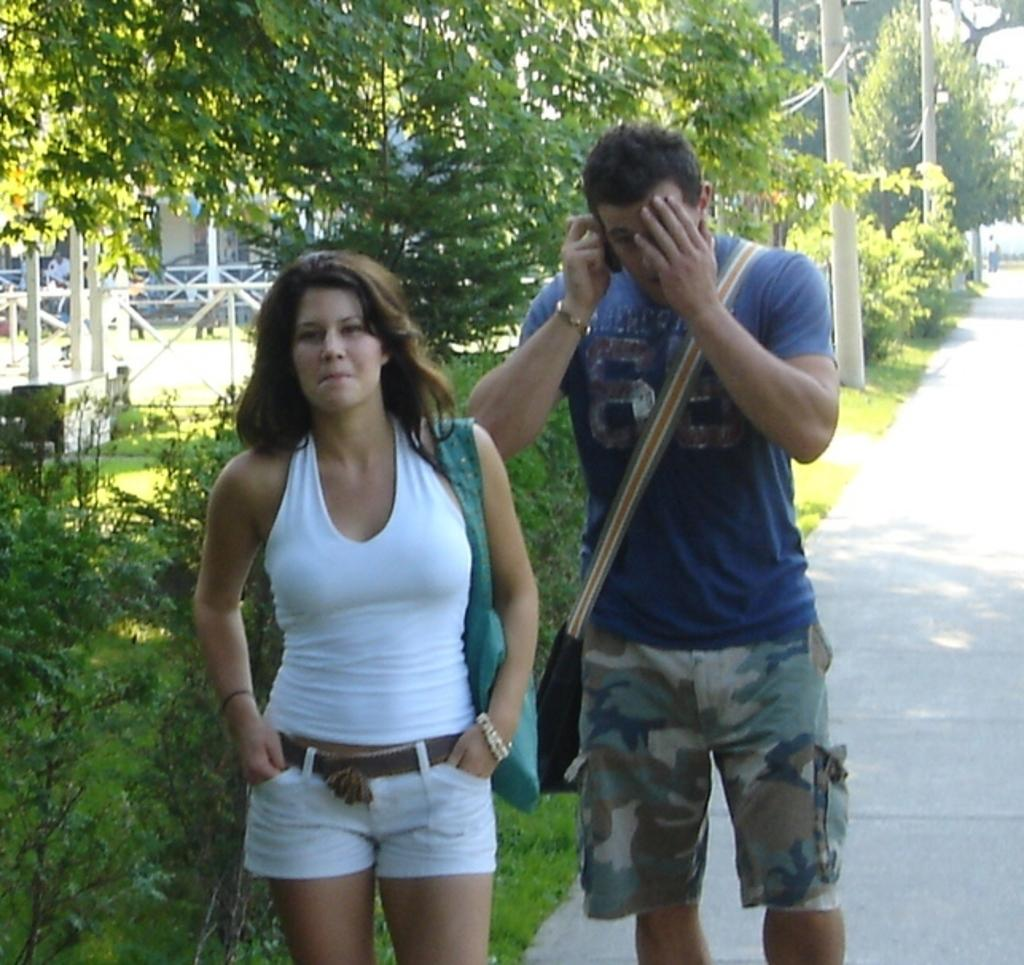Who is the main subject in the image? There is a man in the image. What is the man doing in the image? The man appears to be talking on the phone. Can you describe the woman in the image? There is a woman standing in the foreground of the image. What can be seen in the background of the image? There are trees, a house, and poles in the background of the image. What direction is the ice pointing towards in the image? There is no ice present in the image, so it is not possible to determine the direction it might be pointing. 